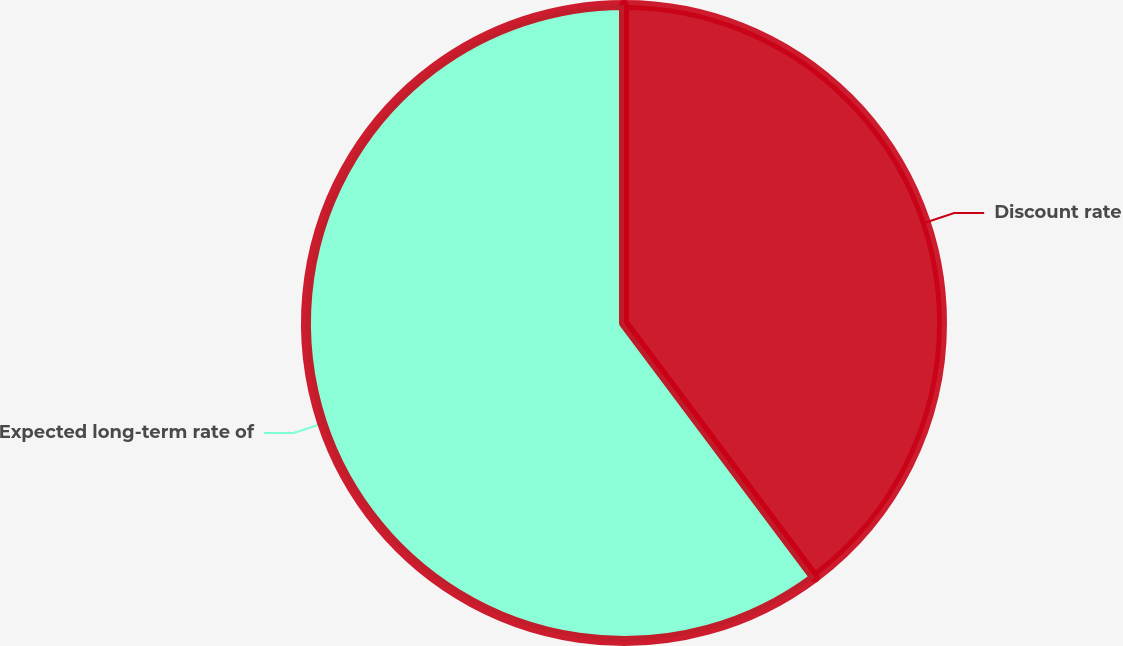Convert chart. <chart><loc_0><loc_0><loc_500><loc_500><pie_chart><fcel>Discount rate<fcel>Expected long-term rate of<nl><fcel>39.76%<fcel>60.24%<nl></chart> 